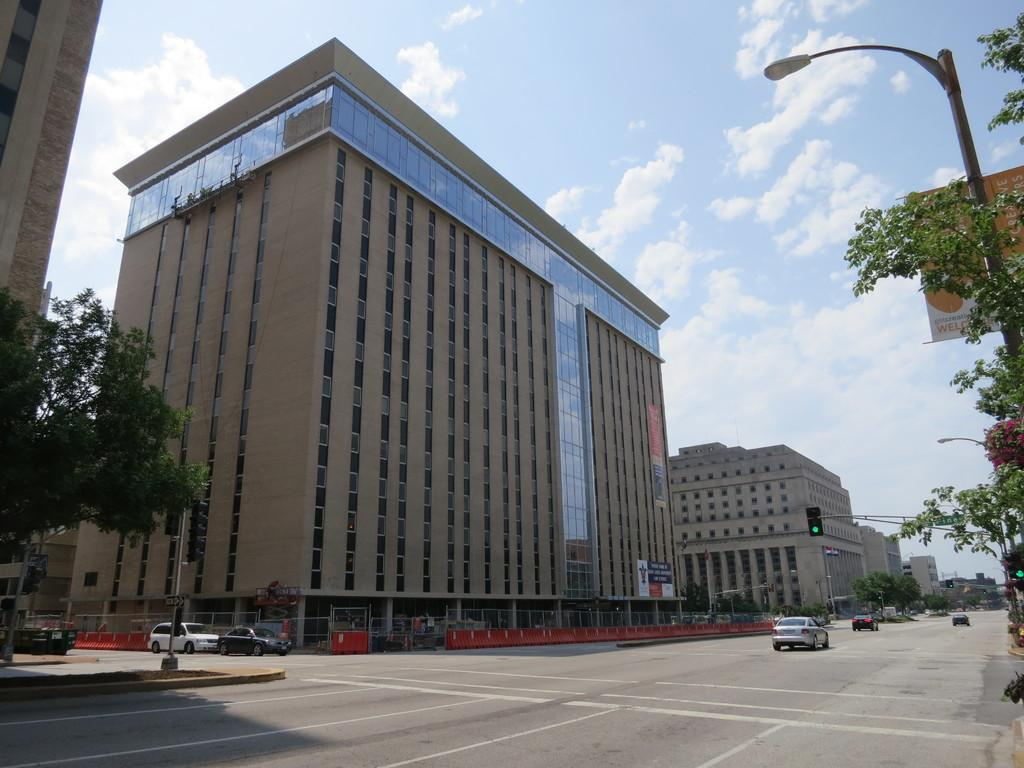What is located in the center of the image? In the center of the image, there are buildings, trees, poles, banners, glass, a wall, a fence, and a traffic light. What types of vehicles can be seen on the road in the image? There are vehicles on the road in the center of the image. What can be seen in the background of the image? The sky, clouds, and possibly more buildings can be seen in the background of the image. How many dust particles can be seen floating in the air in the image? There is no mention of dust particles in the image, so it is not possible to determine their number. Can you tell me how many cats are sitting on the wall in the image? There are no cats present in the image; the wall is part of the buildings and has no visible animals. 